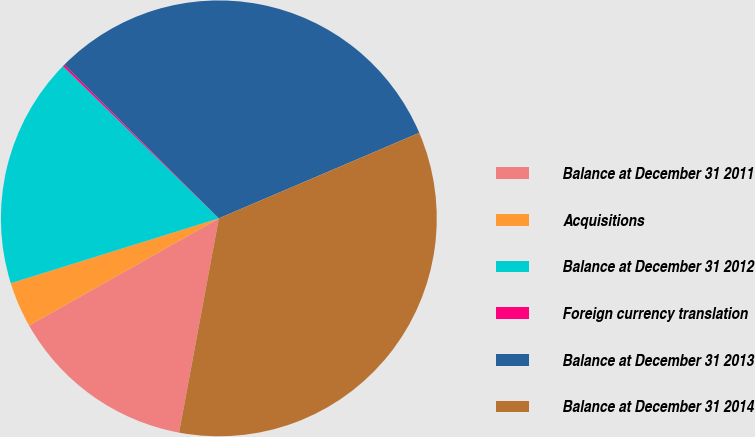<chart> <loc_0><loc_0><loc_500><loc_500><pie_chart><fcel>Balance at December 31 2011<fcel>Acquisitions<fcel>Balance at December 31 2012<fcel>Foreign currency translation<fcel>Balance at December 31 2013<fcel>Balance at December 31 2014<nl><fcel>13.9%<fcel>3.37%<fcel>17.12%<fcel>0.15%<fcel>31.12%<fcel>34.34%<nl></chart> 